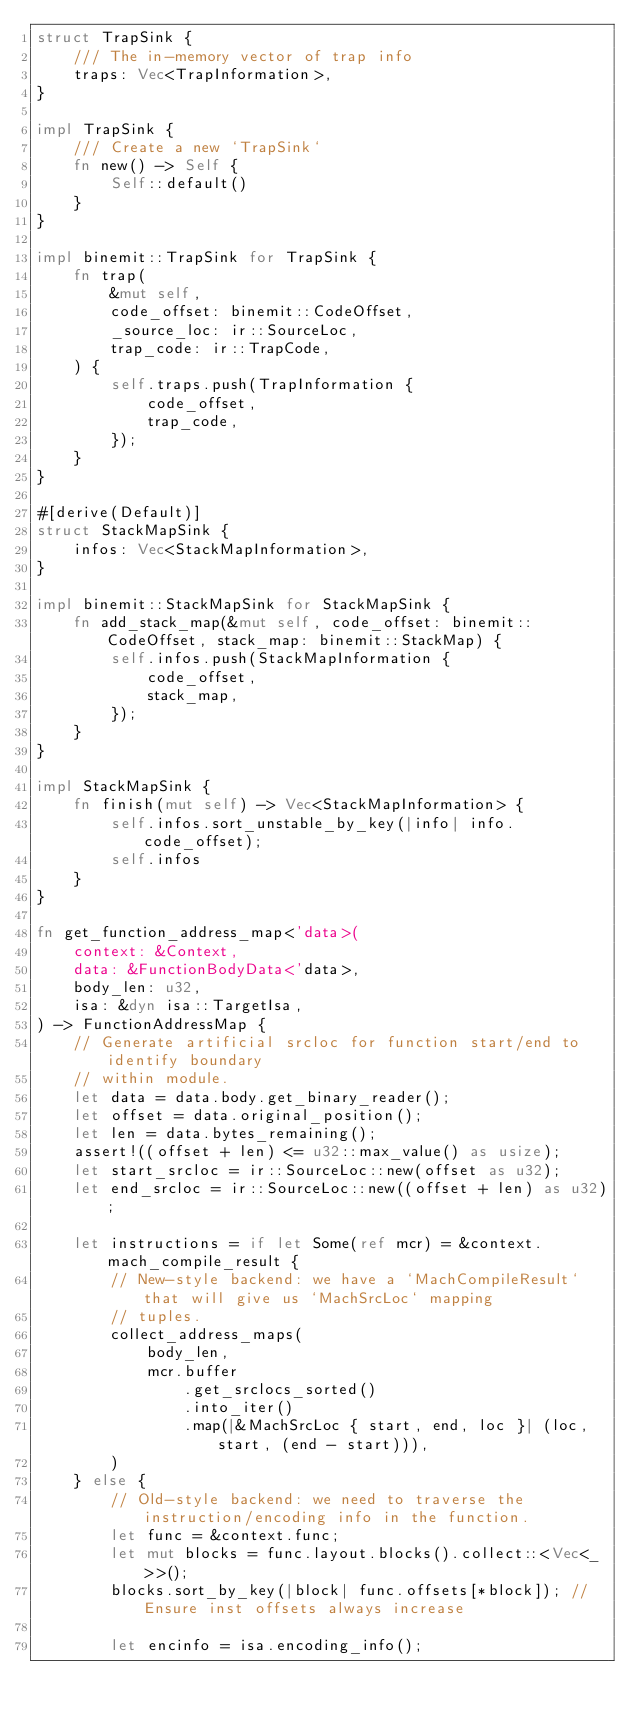<code> <loc_0><loc_0><loc_500><loc_500><_Rust_>struct TrapSink {
    /// The in-memory vector of trap info
    traps: Vec<TrapInformation>,
}

impl TrapSink {
    /// Create a new `TrapSink`
    fn new() -> Self {
        Self::default()
    }
}

impl binemit::TrapSink for TrapSink {
    fn trap(
        &mut self,
        code_offset: binemit::CodeOffset,
        _source_loc: ir::SourceLoc,
        trap_code: ir::TrapCode,
    ) {
        self.traps.push(TrapInformation {
            code_offset,
            trap_code,
        });
    }
}

#[derive(Default)]
struct StackMapSink {
    infos: Vec<StackMapInformation>,
}

impl binemit::StackMapSink for StackMapSink {
    fn add_stack_map(&mut self, code_offset: binemit::CodeOffset, stack_map: binemit::StackMap) {
        self.infos.push(StackMapInformation {
            code_offset,
            stack_map,
        });
    }
}

impl StackMapSink {
    fn finish(mut self) -> Vec<StackMapInformation> {
        self.infos.sort_unstable_by_key(|info| info.code_offset);
        self.infos
    }
}

fn get_function_address_map<'data>(
    context: &Context,
    data: &FunctionBodyData<'data>,
    body_len: u32,
    isa: &dyn isa::TargetIsa,
) -> FunctionAddressMap {
    // Generate artificial srcloc for function start/end to identify boundary
    // within module.
    let data = data.body.get_binary_reader();
    let offset = data.original_position();
    let len = data.bytes_remaining();
    assert!((offset + len) <= u32::max_value() as usize);
    let start_srcloc = ir::SourceLoc::new(offset as u32);
    let end_srcloc = ir::SourceLoc::new((offset + len) as u32);

    let instructions = if let Some(ref mcr) = &context.mach_compile_result {
        // New-style backend: we have a `MachCompileResult` that will give us `MachSrcLoc` mapping
        // tuples.
        collect_address_maps(
            body_len,
            mcr.buffer
                .get_srclocs_sorted()
                .into_iter()
                .map(|&MachSrcLoc { start, end, loc }| (loc, start, (end - start))),
        )
    } else {
        // Old-style backend: we need to traverse the instruction/encoding info in the function.
        let func = &context.func;
        let mut blocks = func.layout.blocks().collect::<Vec<_>>();
        blocks.sort_by_key(|block| func.offsets[*block]); // Ensure inst offsets always increase

        let encinfo = isa.encoding_info();</code> 